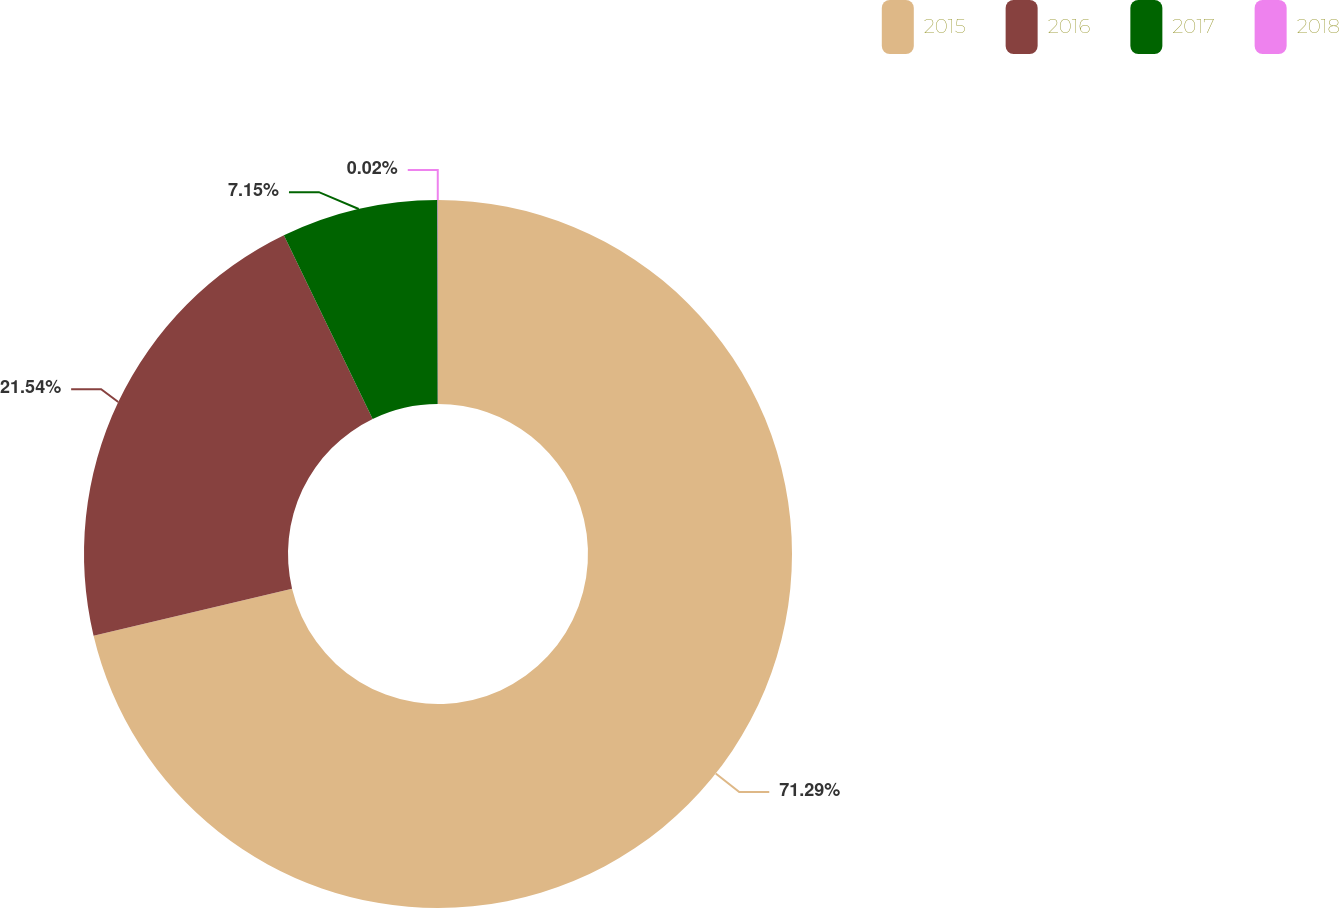Convert chart. <chart><loc_0><loc_0><loc_500><loc_500><pie_chart><fcel>2015<fcel>2016<fcel>2017<fcel>2018<nl><fcel>71.29%<fcel>21.54%<fcel>7.15%<fcel>0.02%<nl></chart> 